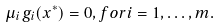<formula> <loc_0><loc_0><loc_500><loc_500>\mu _ { i } g _ { i } ( x ^ { * } ) = 0 , { f o r } i = 1 , \dots , m .</formula> 